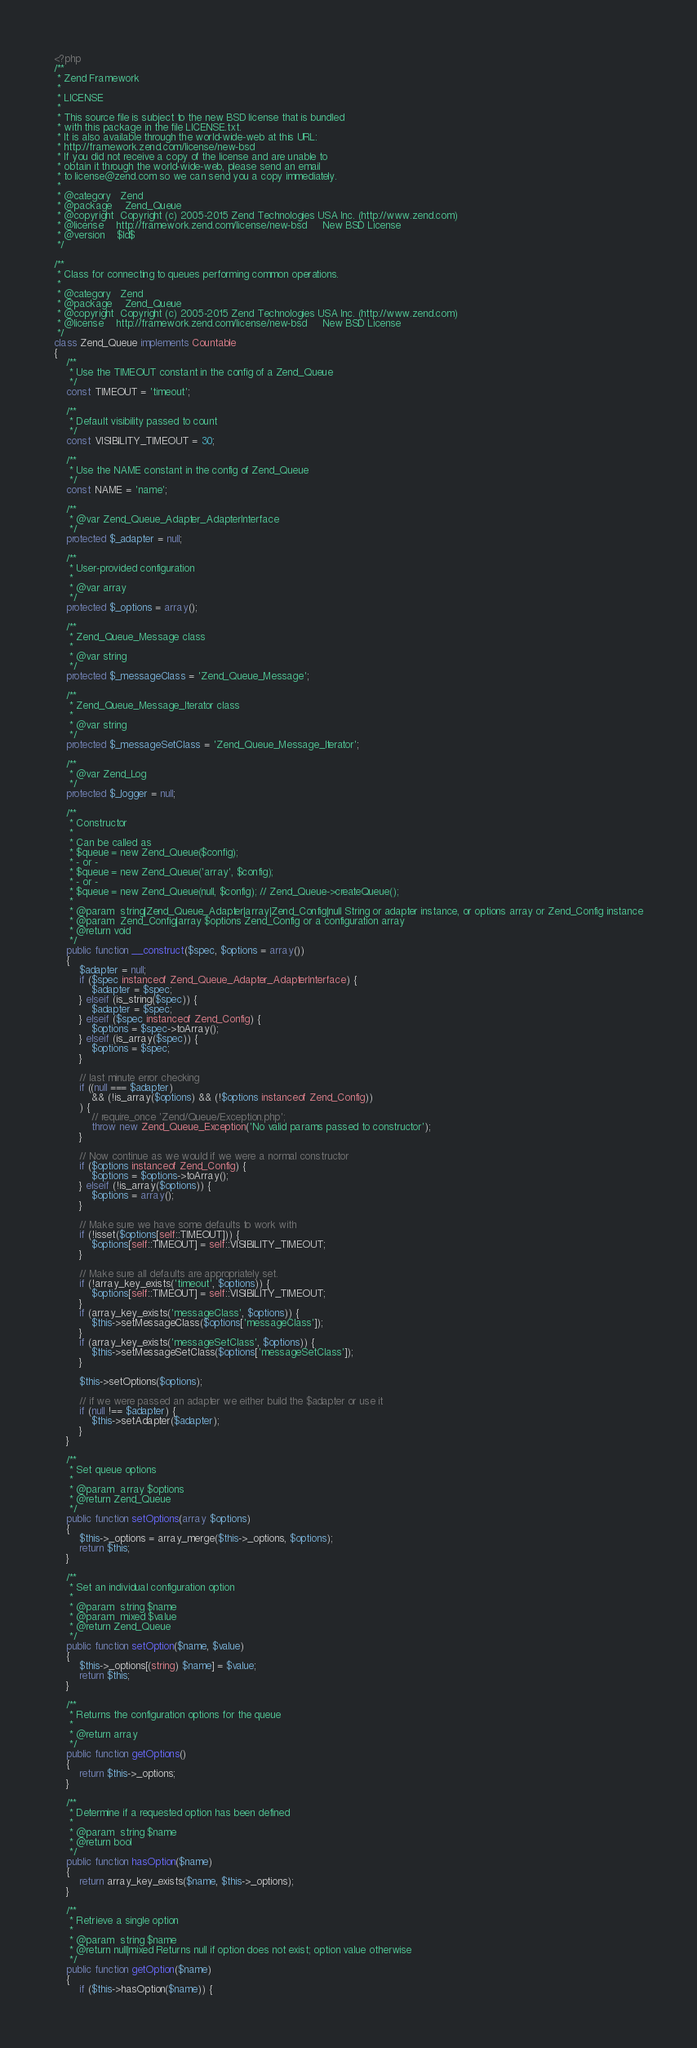Convert code to text. <code><loc_0><loc_0><loc_500><loc_500><_PHP_><?php
/**
 * Zend Framework
 *
 * LICENSE
 *
 * This source file is subject to the new BSD license that is bundled
 * with this package in the file LICENSE.txt.
 * It is also available through the world-wide-web at this URL:
 * http://framework.zend.com/license/new-bsd
 * If you did not receive a copy of the license and are unable to
 * obtain it through the world-wide-web, please send an email
 * to license@zend.com so we can send you a copy immediately.
 *
 * @category   Zend
 * @package    Zend_Queue
 * @copyright  Copyright (c) 2005-2015 Zend Technologies USA Inc. (http://www.zend.com)
 * @license    http://framework.zend.com/license/new-bsd     New BSD License
 * @version    $Id$
 */

/**
 * Class for connecting to queues performing common operations.
 *
 * @category   Zend
 * @package    Zend_Queue
 * @copyright  Copyright (c) 2005-2015 Zend Technologies USA Inc. (http://www.zend.com)
 * @license    http://framework.zend.com/license/new-bsd     New BSD License
 */
class Zend_Queue implements Countable
{
    /**
     * Use the TIMEOUT constant in the config of a Zend_Queue
     */
    const TIMEOUT = 'timeout';

    /**
     * Default visibility passed to count
     */
    const VISIBILITY_TIMEOUT = 30;

    /**
     * Use the NAME constant in the config of Zend_Queue
     */
    const NAME = 'name';

    /**
     * @var Zend_Queue_Adapter_AdapterInterface
     */
    protected $_adapter = null;

    /**
     * User-provided configuration
     *
     * @var array
     */
    protected $_options = array();

    /**
     * Zend_Queue_Message class
     *
     * @var string
     */
    protected $_messageClass = 'Zend_Queue_Message';

    /**
     * Zend_Queue_Message_Iterator class
     *
     * @var string
     */
    protected $_messageSetClass = 'Zend_Queue_Message_Iterator';

    /**
     * @var Zend_Log
     */
    protected $_logger = null;

    /**
     * Constructor
     *
     * Can be called as
     * $queue = new Zend_Queue($config);
     * - or -
     * $queue = new Zend_Queue('array', $config);
     * - or -
     * $queue = new Zend_Queue(null, $config); // Zend_Queue->createQueue();
     *
     * @param  string|Zend_Queue_Adapter|array|Zend_Config|null String or adapter instance, or options array or Zend_Config instance
     * @param  Zend_Config|array $options Zend_Config or a configuration array
     * @return void
     */
    public function __construct($spec, $options = array())
    {
        $adapter = null;
        if ($spec instanceof Zend_Queue_Adapter_AdapterInterface) {
            $adapter = $spec;
        } elseif (is_string($spec)) {
            $adapter = $spec;
        } elseif ($spec instanceof Zend_Config) {
            $options = $spec->toArray();
        } elseif (is_array($spec)) {
            $options = $spec;
        }

        // last minute error checking
        if ((null === $adapter)
            && (!is_array($options) && (!$options instanceof Zend_Config))
        ) {
            // require_once 'Zend/Queue/Exception.php';
            throw new Zend_Queue_Exception('No valid params passed to constructor');
        }

        // Now continue as we would if we were a normal constructor
        if ($options instanceof Zend_Config) {
            $options = $options->toArray();
        } elseif (!is_array($options)) {
            $options = array();
        }

        // Make sure we have some defaults to work with
        if (!isset($options[self::TIMEOUT])) {
            $options[self::TIMEOUT] = self::VISIBILITY_TIMEOUT;
        }

        // Make sure all defaults are appropriately set.
        if (!array_key_exists('timeout', $options)) {
            $options[self::TIMEOUT] = self::VISIBILITY_TIMEOUT;
        }
        if (array_key_exists('messageClass', $options)) {
            $this->setMessageClass($options['messageClass']);
        }
        if (array_key_exists('messageSetClass', $options)) {
            $this->setMessageSetClass($options['messageSetClass']);
        }

        $this->setOptions($options);

        // if we were passed an adapter we either build the $adapter or use it
        if (null !== $adapter) {
            $this->setAdapter($adapter);
        }
    }

    /**
     * Set queue options
     *
     * @param  array $options
     * @return Zend_Queue
     */
    public function setOptions(array $options)
    {
        $this->_options = array_merge($this->_options, $options);
        return $this;
    }

    /**
     * Set an individual configuration option
     *
     * @param  string $name
     * @param  mixed $value
     * @return Zend_Queue
     */
    public function setOption($name, $value)
    {
        $this->_options[(string) $name] = $value;
        return $this;
    }

    /**
     * Returns the configuration options for the queue
     *
     * @return array
     */
    public function getOptions()
    {
        return $this->_options;
    }

    /**
     * Determine if a requested option has been defined
     *
     * @param  string $name
     * @return bool
     */
    public function hasOption($name)
    {
        return array_key_exists($name, $this->_options);
    }

    /**
     * Retrieve a single option
     *
     * @param  string $name
     * @return null|mixed Returns null if option does not exist; option value otherwise
     */
    public function getOption($name)
    {
        if ($this->hasOption($name)) {</code> 